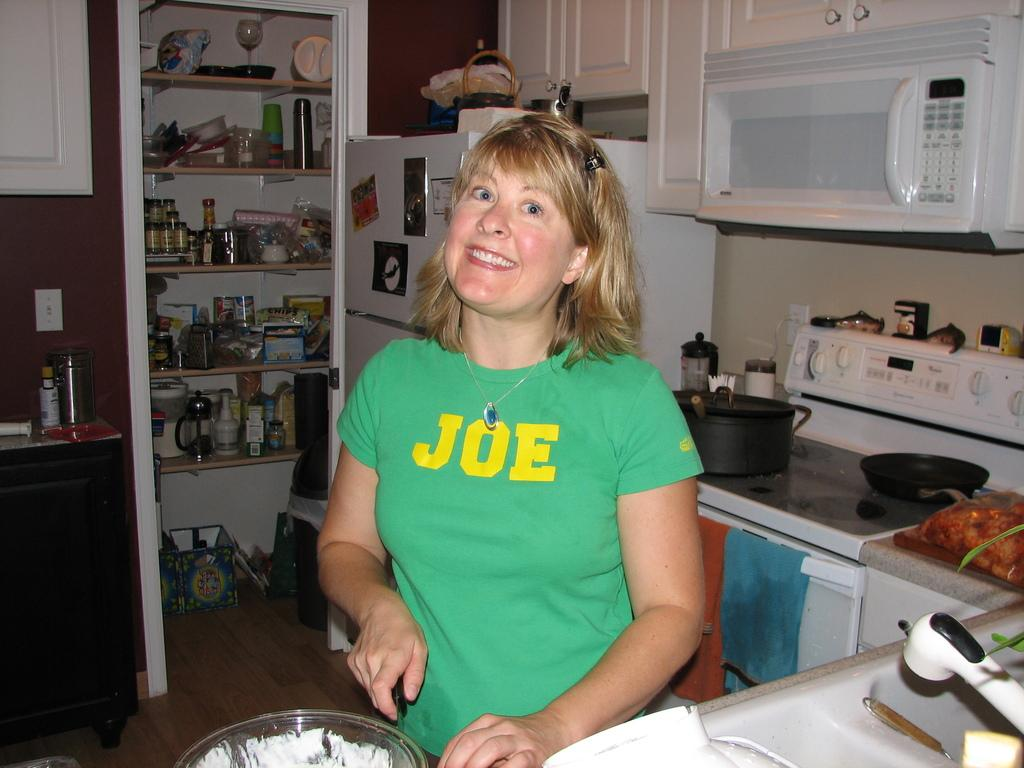<image>
Write a terse but informative summary of the picture. A woman wearing a green shirt that says Joe on it is cooking. 